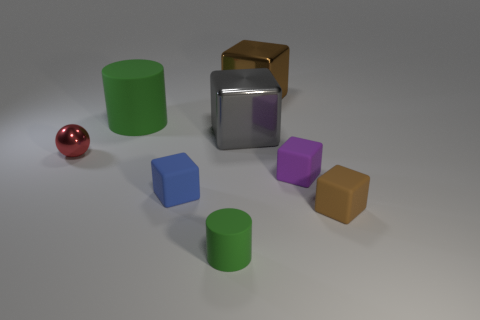Subtract all red cubes. Subtract all blue spheres. How many cubes are left? 5 Add 1 small purple things. How many objects exist? 9 Subtract all cylinders. How many objects are left? 6 Add 8 big blocks. How many big blocks exist? 10 Subtract 1 purple blocks. How many objects are left? 7 Subtract all shiny objects. Subtract all large green cylinders. How many objects are left? 4 Add 3 tiny matte cylinders. How many tiny matte cylinders are left? 4 